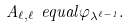Convert formula to latex. <formula><loc_0><loc_0><loc_500><loc_500>A _ { \ell , \ell } { \ e q u a l } \varphi _ { \lambda ^ { \ell - 1 } } .</formula> 